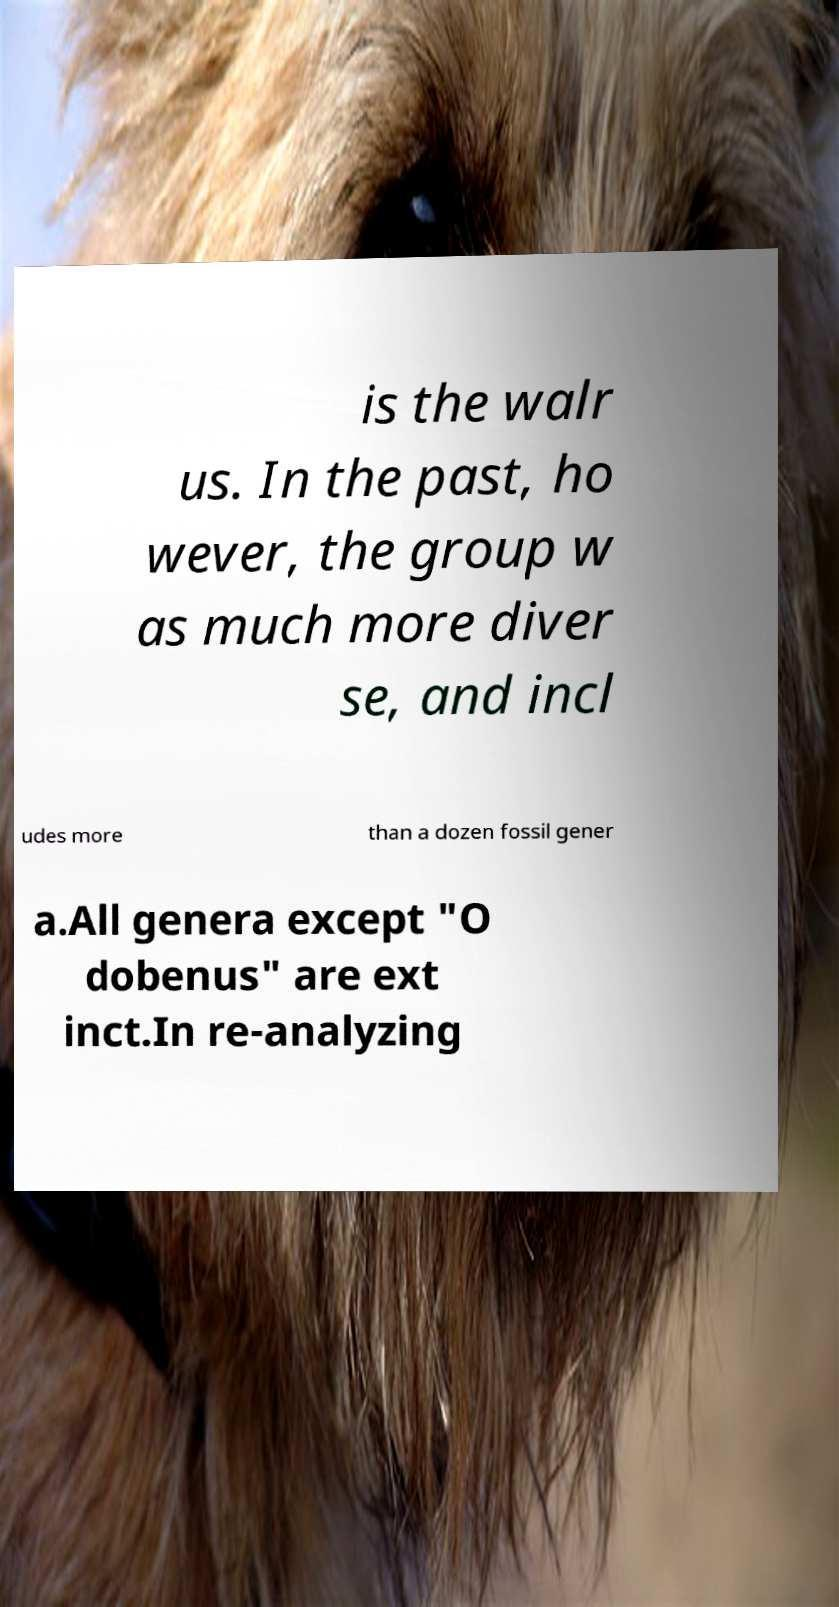Can you read and provide the text displayed in the image?This photo seems to have some interesting text. Can you extract and type it out for me? is the walr us. In the past, ho wever, the group w as much more diver se, and incl udes more than a dozen fossil gener a.All genera except "O dobenus" are ext inct.In re-analyzing 